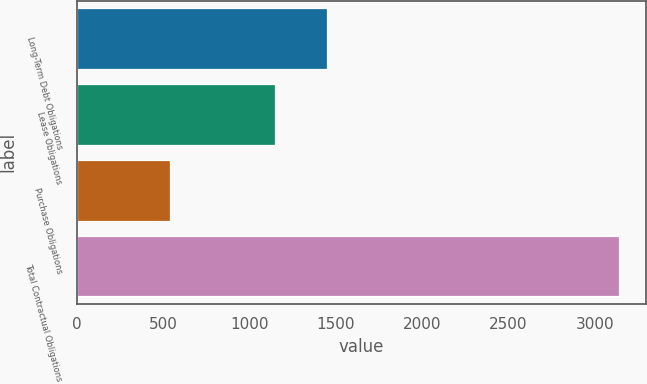<chart> <loc_0><loc_0><loc_500><loc_500><bar_chart><fcel>Long-Term Debt Obligations<fcel>Lease Obligations<fcel>Purchase Obligations<fcel>Total Contractual Obligations<nl><fcel>1451<fcel>1151<fcel>539<fcel>3141<nl></chart> 